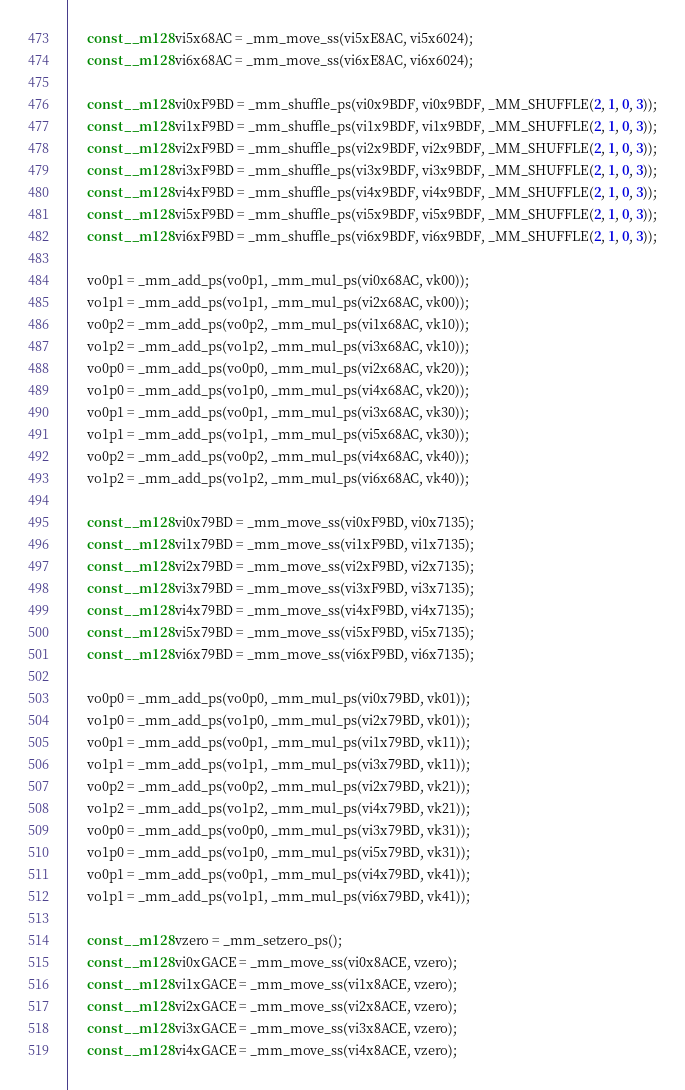Convert code to text. <code><loc_0><loc_0><loc_500><loc_500><_C_>      const __m128 vi5x68AC = _mm_move_ss(vi5xE8AC, vi5x6024);
      const __m128 vi6x68AC = _mm_move_ss(vi6xE8AC, vi6x6024);

      const __m128 vi0xF9BD = _mm_shuffle_ps(vi0x9BDF, vi0x9BDF, _MM_SHUFFLE(2, 1, 0, 3));
      const __m128 vi1xF9BD = _mm_shuffle_ps(vi1x9BDF, vi1x9BDF, _MM_SHUFFLE(2, 1, 0, 3));
      const __m128 vi2xF9BD = _mm_shuffle_ps(vi2x9BDF, vi2x9BDF, _MM_SHUFFLE(2, 1, 0, 3));
      const __m128 vi3xF9BD = _mm_shuffle_ps(vi3x9BDF, vi3x9BDF, _MM_SHUFFLE(2, 1, 0, 3));
      const __m128 vi4xF9BD = _mm_shuffle_ps(vi4x9BDF, vi4x9BDF, _MM_SHUFFLE(2, 1, 0, 3));
      const __m128 vi5xF9BD = _mm_shuffle_ps(vi5x9BDF, vi5x9BDF, _MM_SHUFFLE(2, 1, 0, 3));
      const __m128 vi6xF9BD = _mm_shuffle_ps(vi6x9BDF, vi6x9BDF, _MM_SHUFFLE(2, 1, 0, 3));

      vo0p1 = _mm_add_ps(vo0p1, _mm_mul_ps(vi0x68AC, vk00));
      vo1p1 = _mm_add_ps(vo1p1, _mm_mul_ps(vi2x68AC, vk00));
      vo0p2 = _mm_add_ps(vo0p2, _mm_mul_ps(vi1x68AC, vk10));
      vo1p2 = _mm_add_ps(vo1p2, _mm_mul_ps(vi3x68AC, vk10));
      vo0p0 = _mm_add_ps(vo0p0, _mm_mul_ps(vi2x68AC, vk20));
      vo1p0 = _mm_add_ps(vo1p0, _mm_mul_ps(vi4x68AC, vk20));
      vo0p1 = _mm_add_ps(vo0p1, _mm_mul_ps(vi3x68AC, vk30));
      vo1p1 = _mm_add_ps(vo1p1, _mm_mul_ps(vi5x68AC, vk30));
      vo0p2 = _mm_add_ps(vo0p2, _mm_mul_ps(vi4x68AC, vk40));
      vo1p2 = _mm_add_ps(vo1p2, _mm_mul_ps(vi6x68AC, vk40));

      const __m128 vi0x79BD = _mm_move_ss(vi0xF9BD, vi0x7135);
      const __m128 vi1x79BD = _mm_move_ss(vi1xF9BD, vi1x7135);
      const __m128 vi2x79BD = _mm_move_ss(vi2xF9BD, vi2x7135);
      const __m128 vi3x79BD = _mm_move_ss(vi3xF9BD, vi3x7135);
      const __m128 vi4x79BD = _mm_move_ss(vi4xF9BD, vi4x7135);
      const __m128 vi5x79BD = _mm_move_ss(vi5xF9BD, vi5x7135);
      const __m128 vi6x79BD = _mm_move_ss(vi6xF9BD, vi6x7135);

      vo0p0 = _mm_add_ps(vo0p0, _mm_mul_ps(vi0x79BD, vk01));
      vo1p0 = _mm_add_ps(vo1p0, _mm_mul_ps(vi2x79BD, vk01));
      vo0p1 = _mm_add_ps(vo0p1, _mm_mul_ps(vi1x79BD, vk11));
      vo1p1 = _mm_add_ps(vo1p1, _mm_mul_ps(vi3x79BD, vk11));
      vo0p2 = _mm_add_ps(vo0p2, _mm_mul_ps(vi2x79BD, vk21));
      vo1p2 = _mm_add_ps(vo1p2, _mm_mul_ps(vi4x79BD, vk21));
      vo0p0 = _mm_add_ps(vo0p0, _mm_mul_ps(vi3x79BD, vk31));
      vo1p0 = _mm_add_ps(vo1p0, _mm_mul_ps(vi5x79BD, vk31));
      vo0p1 = _mm_add_ps(vo0p1, _mm_mul_ps(vi4x79BD, vk41));
      vo1p1 = _mm_add_ps(vo1p1, _mm_mul_ps(vi6x79BD, vk41));

      const __m128 vzero = _mm_setzero_ps();
      const __m128 vi0xGACE = _mm_move_ss(vi0x8ACE, vzero);
      const __m128 vi1xGACE = _mm_move_ss(vi1x8ACE, vzero);
      const __m128 vi2xGACE = _mm_move_ss(vi2x8ACE, vzero);
      const __m128 vi3xGACE = _mm_move_ss(vi3x8ACE, vzero);
      const __m128 vi4xGACE = _mm_move_ss(vi4x8ACE, vzero);</code> 